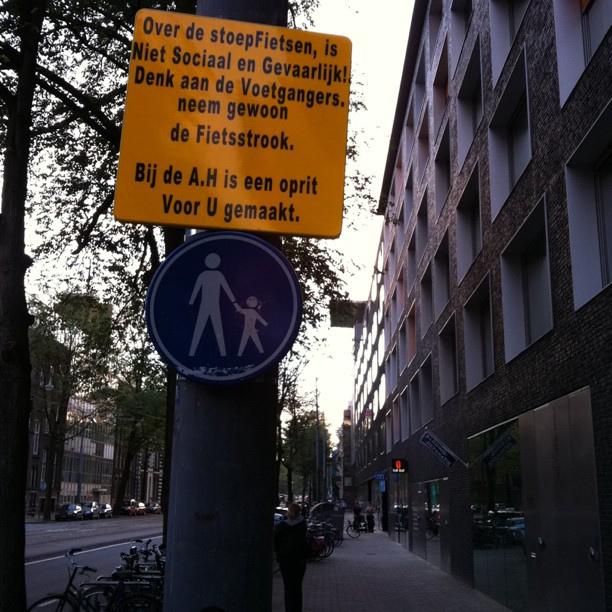What color is the sign on top?
Write a very short answer. Yellow. Is this an English sign?
Give a very brief answer. No. What language is this sign written in?
Short answer required. German. 